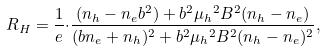<formula> <loc_0><loc_0><loc_500><loc_500>R _ { H } = \frac { 1 } { e } { \cdot } \frac { ( n _ { h } - n _ { e } b ^ { 2 } ) + b ^ { 2 } { \mu _ { h } } ^ { 2 } B ^ { 2 } ( n _ { h } - n _ { e } ) } { ( b n _ { e } + n _ { h } ) ^ { 2 } + b ^ { 2 } { \mu _ { h } } ^ { 2 } B ^ { 2 } ( n _ { h } - n _ { e } ) ^ { 2 } } ,</formula> 